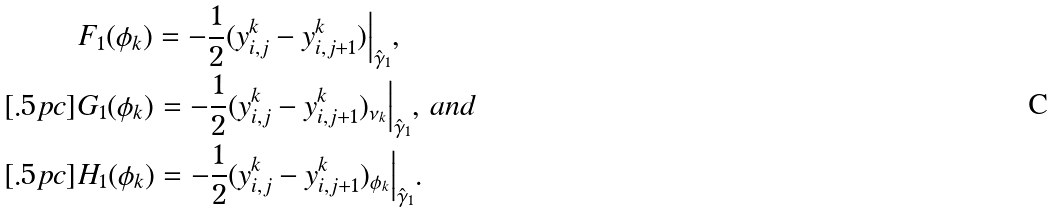<formula> <loc_0><loc_0><loc_500><loc_500>& F _ { 1 } ( \phi _ { k } ) = - \frac { 1 } { 2 } ( y _ { i , j } ^ { k } - y _ { i , j + 1 } ^ { k } ) \Big | _ { \hat { \gamma } _ { 1 } } , \\ [ . 5 p c ] & G _ { 1 } ( \phi _ { k } ) = - \frac { 1 } { 2 } ( y _ { i , j } ^ { k } - y _ { i , j + 1 } ^ { k } ) _ { \nu _ { k } } \Big | _ { \hat { \gamma } _ { 1 } } , \, a n d \\ [ . 5 p c ] & H _ { 1 } ( \phi _ { k } ) = - \frac { 1 } { 2 } ( y _ { i , j } ^ { k } - y _ { i , j + 1 } ^ { k } ) _ { \phi _ { k } } \Big | _ { \hat { \gamma } _ { 1 } } .</formula> 